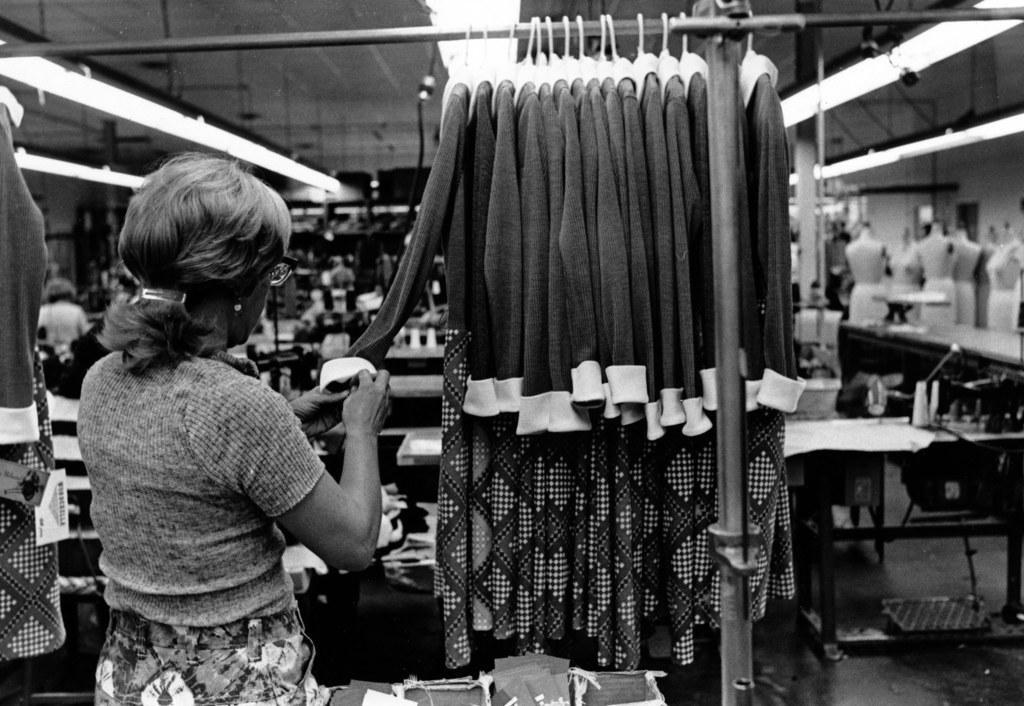Describe this image in one or two sentences. This picture shows a women holding a cloth in her hands and we see few clothes to the hangers and few machines and few mannequins on the side. 